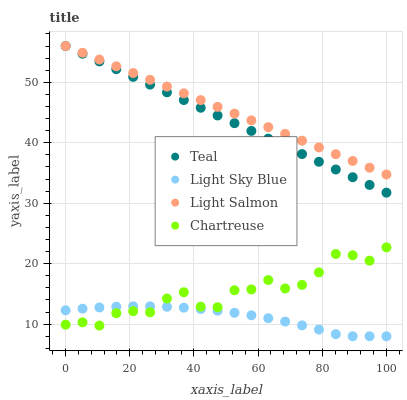Does Light Sky Blue have the minimum area under the curve?
Answer yes or no. Yes. Does Light Salmon have the maximum area under the curve?
Answer yes or no. Yes. Does Chartreuse have the minimum area under the curve?
Answer yes or no. No. Does Chartreuse have the maximum area under the curve?
Answer yes or no. No. Is Teal the smoothest?
Answer yes or no. Yes. Is Chartreuse the roughest?
Answer yes or no. Yes. Is Light Sky Blue the smoothest?
Answer yes or no. No. Is Light Sky Blue the roughest?
Answer yes or no. No. Does Light Sky Blue have the lowest value?
Answer yes or no. Yes. Does Chartreuse have the lowest value?
Answer yes or no. No. Does Teal have the highest value?
Answer yes or no. Yes. Does Chartreuse have the highest value?
Answer yes or no. No. Is Light Sky Blue less than Light Salmon?
Answer yes or no. Yes. Is Light Salmon greater than Chartreuse?
Answer yes or no. Yes. Does Teal intersect Light Salmon?
Answer yes or no. Yes. Is Teal less than Light Salmon?
Answer yes or no. No. Is Teal greater than Light Salmon?
Answer yes or no. No. Does Light Sky Blue intersect Light Salmon?
Answer yes or no. No. 